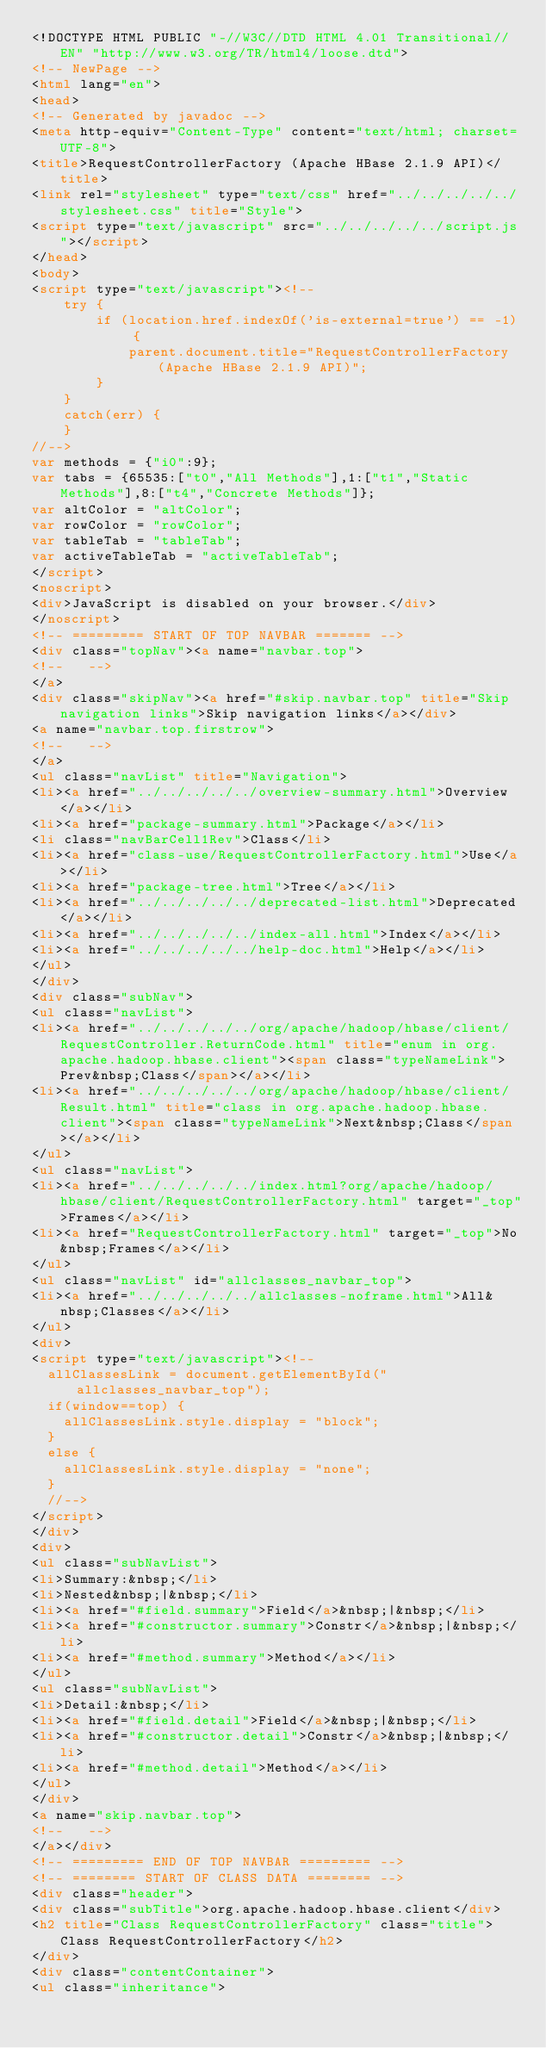<code> <loc_0><loc_0><loc_500><loc_500><_HTML_><!DOCTYPE HTML PUBLIC "-//W3C//DTD HTML 4.01 Transitional//EN" "http://www.w3.org/TR/html4/loose.dtd">
<!-- NewPage -->
<html lang="en">
<head>
<!-- Generated by javadoc -->
<meta http-equiv="Content-Type" content="text/html; charset=UTF-8">
<title>RequestControllerFactory (Apache HBase 2.1.9 API)</title>
<link rel="stylesheet" type="text/css" href="../../../../../stylesheet.css" title="Style">
<script type="text/javascript" src="../../../../../script.js"></script>
</head>
<body>
<script type="text/javascript"><!--
    try {
        if (location.href.indexOf('is-external=true') == -1) {
            parent.document.title="RequestControllerFactory (Apache HBase 2.1.9 API)";
        }
    }
    catch(err) {
    }
//-->
var methods = {"i0":9};
var tabs = {65535:["t0","All Methods"],1:["t1","Static Methods"],8:["t4","Concrete Methods"]};
var altColor = "altColor";
var rowColor = "rowColor";
var tableTab = "tableTab";
var activeTableTab = "activeTableTab";
</script>
<noscript>
<div>JavaScript is disabled on your browser.</div>
</noscript>
<!-- ========= START OF TOP NAVBAR ======= -->
<div class="topNav"><a name="navbar.top">
<!--   -->
</a>
<div class="skipNav"><a href="#skip.navbar.top" title="Skip navigation links">Skip navigation links</a></div>
<a name="navbar.top.firstrow">
<!--   -->
</a>
<ul class="navList" title="Navigation">
<li><a href="../../../../../overview-summary.html">Overview</a></li>
<li><a href="package-summary.html">Package</a></li>
<li class="navBarCell1Rev">Class</li>
<li><a href="class-use/RequestControllerFactory.html">Use</a></li>
<li><a href="package-tree.html">Tree</a></li>
<li><a href="../../../../../deprecated-list.html">Deprecated</a></li>
<li><a href="../../../../../index-all.html">Index</a></li>
<li><a href="../../../../../help-doc.html">Help</a></li>
</ul>
</div>
<div class="subNav">
<ul class="navList">
<li><a href="../../../../../org/apache/hadoop/hbase/client/RequestController.ReturnCode.html" title="enum in org.apache.hadoop.hbase.client"><span class="typeNameLink">Prev&nbsp;Class</span></a></li>
<li><a href="../../../../../org/apache/hadoop/hbase/client/Result.html" title="class in org.apache.hadoop.hbase.client"><span class="typeNameLink">Next&nbsp;Class</span></a></li>
</ul>
<ul class="navList">
<li><a href="../../../../../index.html?org/apache/hadoop/hbase/client/RequestControllerFactory.html" target="_top">Frames</a></li>
<li><a href="RequestControllerFactory.html" target="_top">No&nbsp;Frames</a></li>
</ul>
<ul class="navList" id="allclasses_navbar_top">
<li><a href="../../../../../allclasses-noframe.html">All&nbsp;Classes</a></li>
</ul>
<div>
<script type="text/javascript"><!--
  allClassesLink = document.getElementById("allclasses_navbar_top");
  if(window==top) {
    allClassesLink.style.display = "block";
  }
  else {
    allClassesLink.style.display = "none";
  }
  //-->
</script>
</div>
<div>
<ul class="subNavList">
<li>Summary:&nbsp;</li>
<li>Nested&nbsp;|&nbsp;</li>
<li><a href="#field.summary">Field</a>&nbsp;|&nbsp;</li>
<li><a href="#constructor.summary">Constr</a>&nbsp;|&nbsp;</li>
<li><a href="#method.summary">Method</a></li>
</ul>
<ul class="subNavList">
<li>Detail:&nbsp;</li>
<li><a href="#field.detail">Field</a>&nbsp;|&nbsp;</li>
<li><a href="#constructor.detail">Constr</a>&nbsp;|&nbsp;</li>
<li><a href="#method.detail">Method</a></li>
</ul>
</div>
<a name="skip.navbar.top">
<!--   -->
</a></div>
<!-- ========= END OF TOP NAVBAR ========= -->
<!-- ======== START OF CLASS DATA ======== -->
<div class="header">
<div class="subTitle">org.apache.hadoop.hbase.client</div>
<h2 title="Class RequestControllerFactory" class="title">Class RequestControllerFactory</h2>
</div>
<div class="contentContainer">
<ul class="inheritance"></code> 